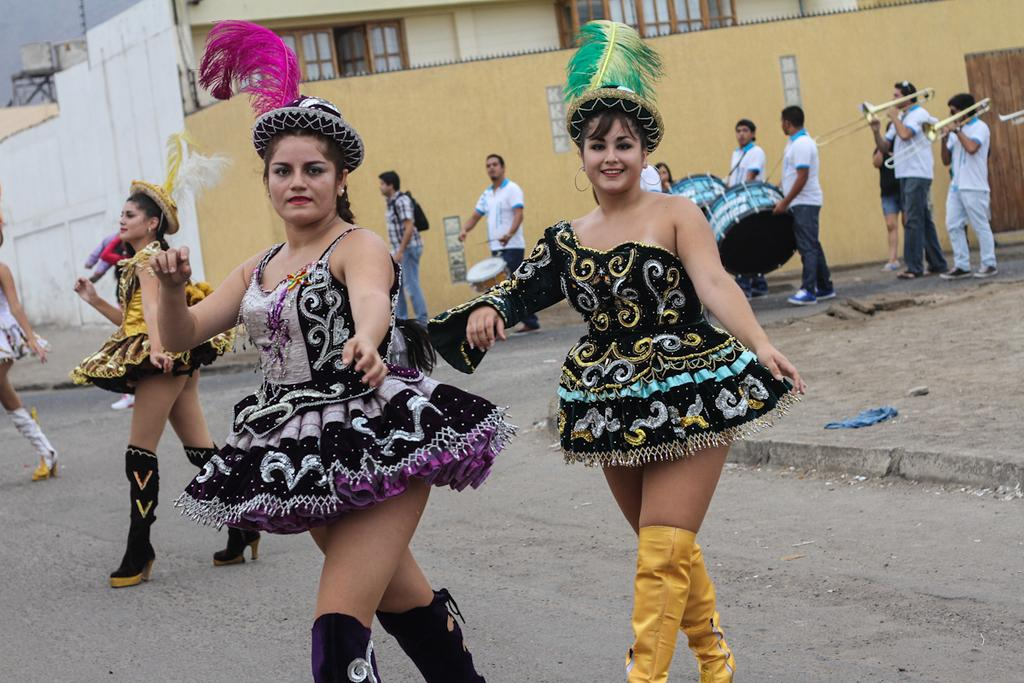What are the women in the middle of the image doing? The women in the middle of the image are standing and smiling. What can be seen behind the women? There are people holding musical instruments behind the women. What is visible in the background of the image? There is a building visible in the background. What type of zipper can be seen on the women's clothing in the image? There is no zipper visible on the women's clothing in the image. What kind of flesh is visible on the women's faces in the image? The women's faces are not described in terms of flesh in the image; they are simply smiling. 